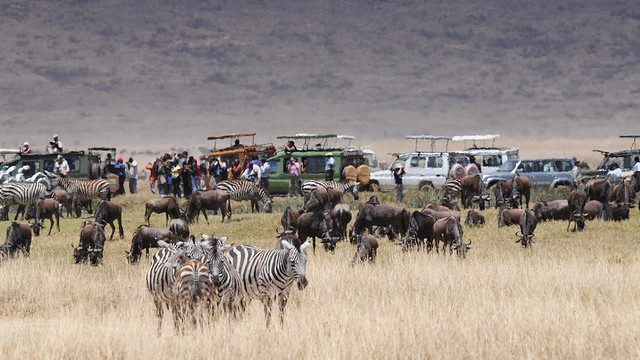Describe the objects in this image and their specific colors. I can see zebra in gray, darkgray, and lightgray tones, people in gray, black, darkgray, and lavender tones, truck in gray, black, and darkgray tones, truck in gray, darkgray, and lightgray tones, and zebra in gray and darkgray tones in this image. 